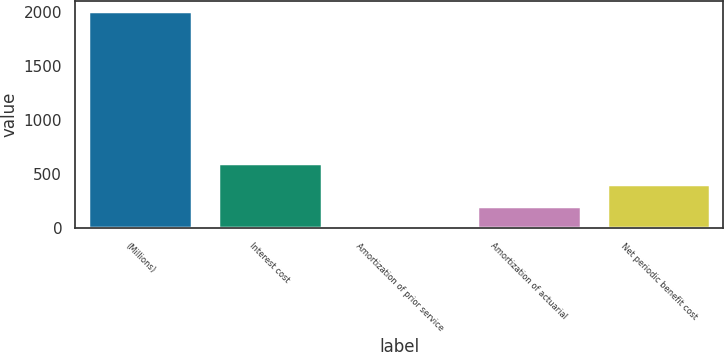Convert chart to OTSL. <chart><loc_0><loc_0><loc_500><loc_500><bar_chart><fcel>(Millions)<fcel>Interest cost<fcel>Amortization of prior service<fcel>Amortization of actuarial<fcel>Net periodic benefit cost<nl><fcel>2009<fcel>606.9<fcel>6<fcel>206.3<fcel>406.6<nl></chart> 